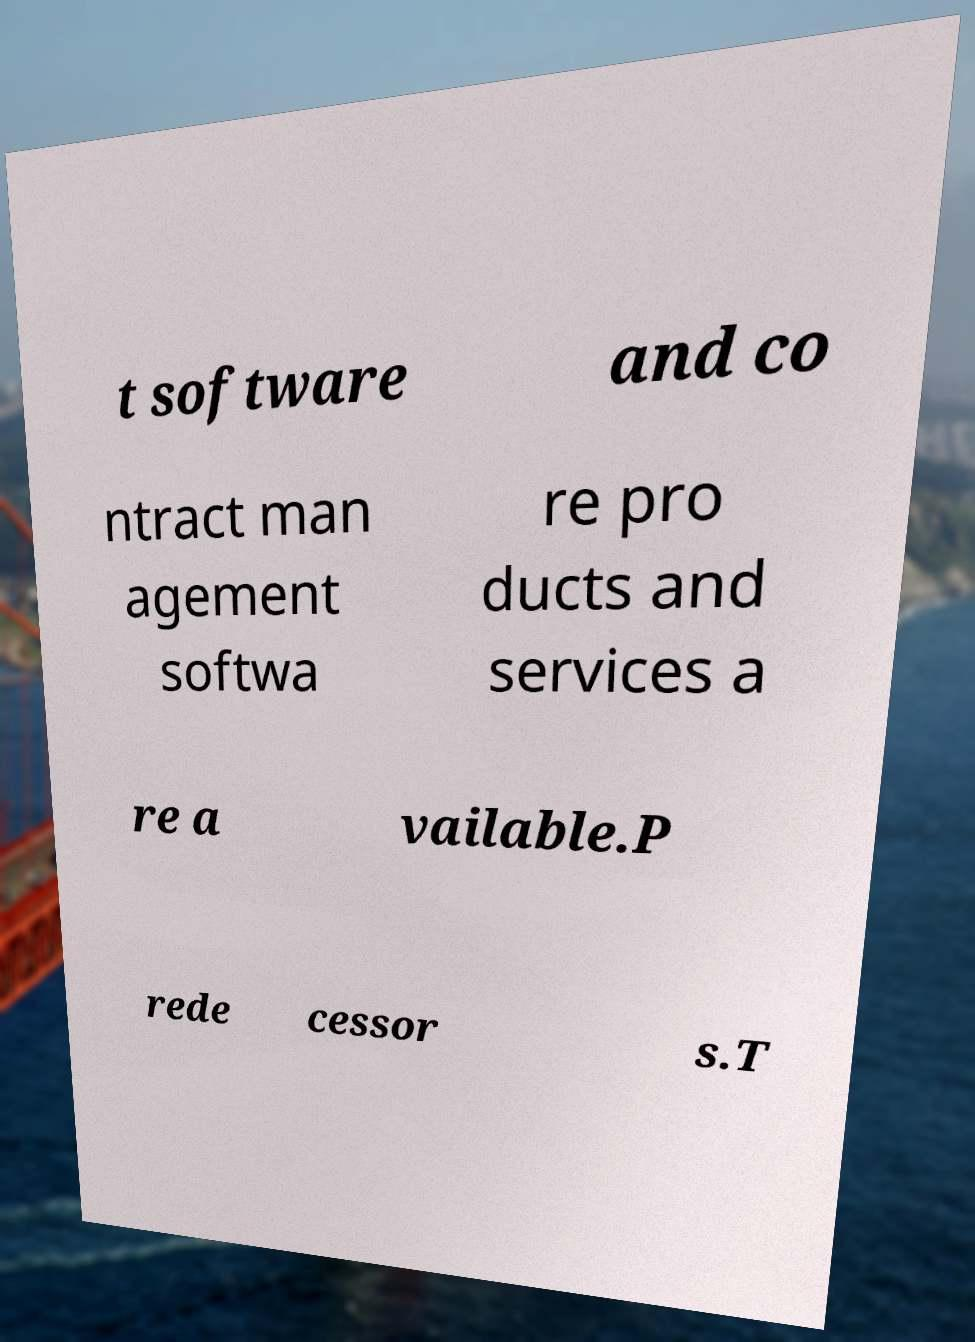Please read and relay the text visible in this image. What does it say? t software and co ntract man agement softwa re pro ducts and services a re a vailable.P rede cessor s.T 